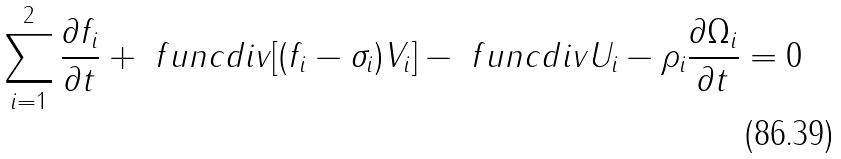<formula> <loc_0><loc_0><loc_500><loc_500>\sum _ { i = 1 } ^ { 2 } \frac { \partial f _ { i } } { \partial t } + \ f u n c { d i v } [ ( f _ { i } - \sigma _ { i } ) V _ { i } ] - \ f u n c { d i v } U _ { i } - \rho _ { i } \frac { \partial \Omega _ { i } } { \partial t } = 0</formula> 